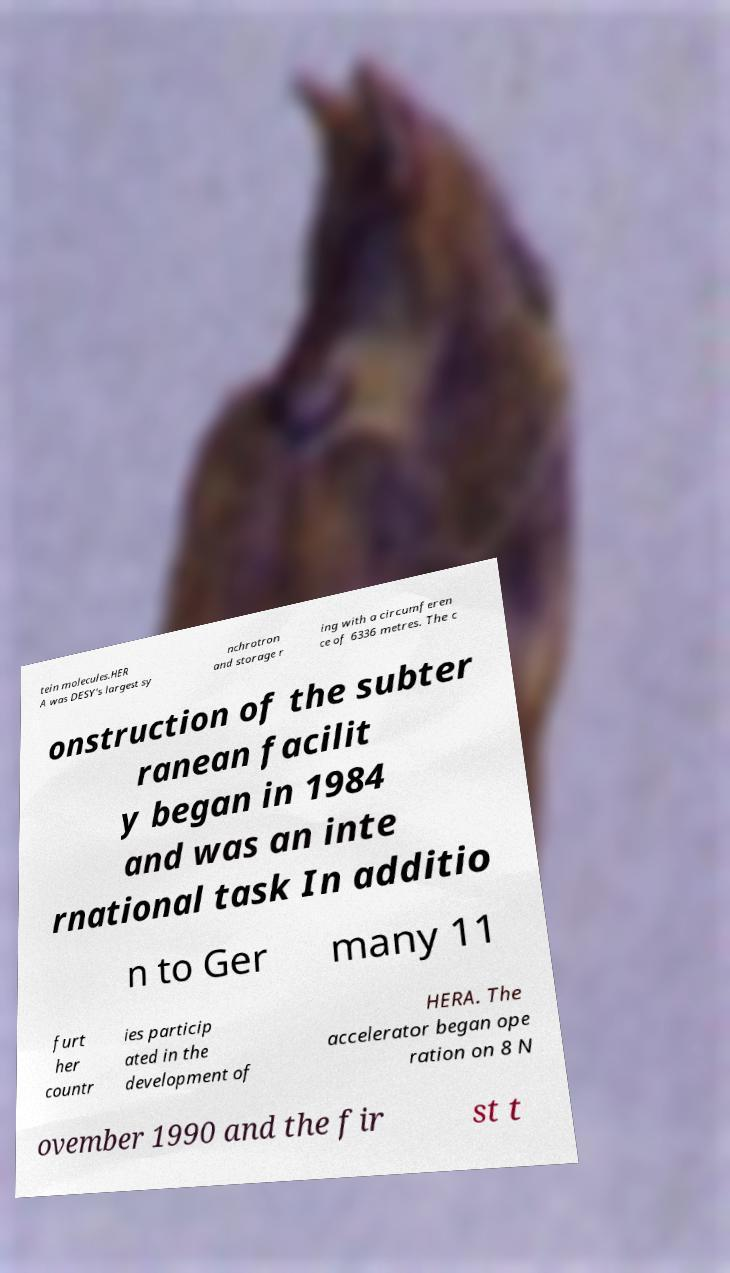For documentation purposes, I need the text within this image transcribed. Could you provide that? tein molecules.HER A was DESY's largest sy nchrotron and storage r ing with a circumferen ce of 6336 metres. The c onstruction of the subter ranean facilit y began in 1984 and was an inte rnational task In additio n to Ger many 11 furt her countr ies particip ated in the development of HERA. The accelerator began ope ration on 8 N ovember 1990 and the fir st t 